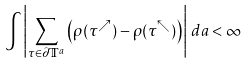Convert formula to latex. <formula><loc_0><loc_0><loc_500><loc_500>\int \left | \sum _ { \tau \in \partial \mathbb { T } ^ { a } } \left ( \rho ( \tau ^ { \nearrow } ) - \rho ( \tau ^ { \nwarrow } ) \right ) \right | \, d a < \infty</formula> 